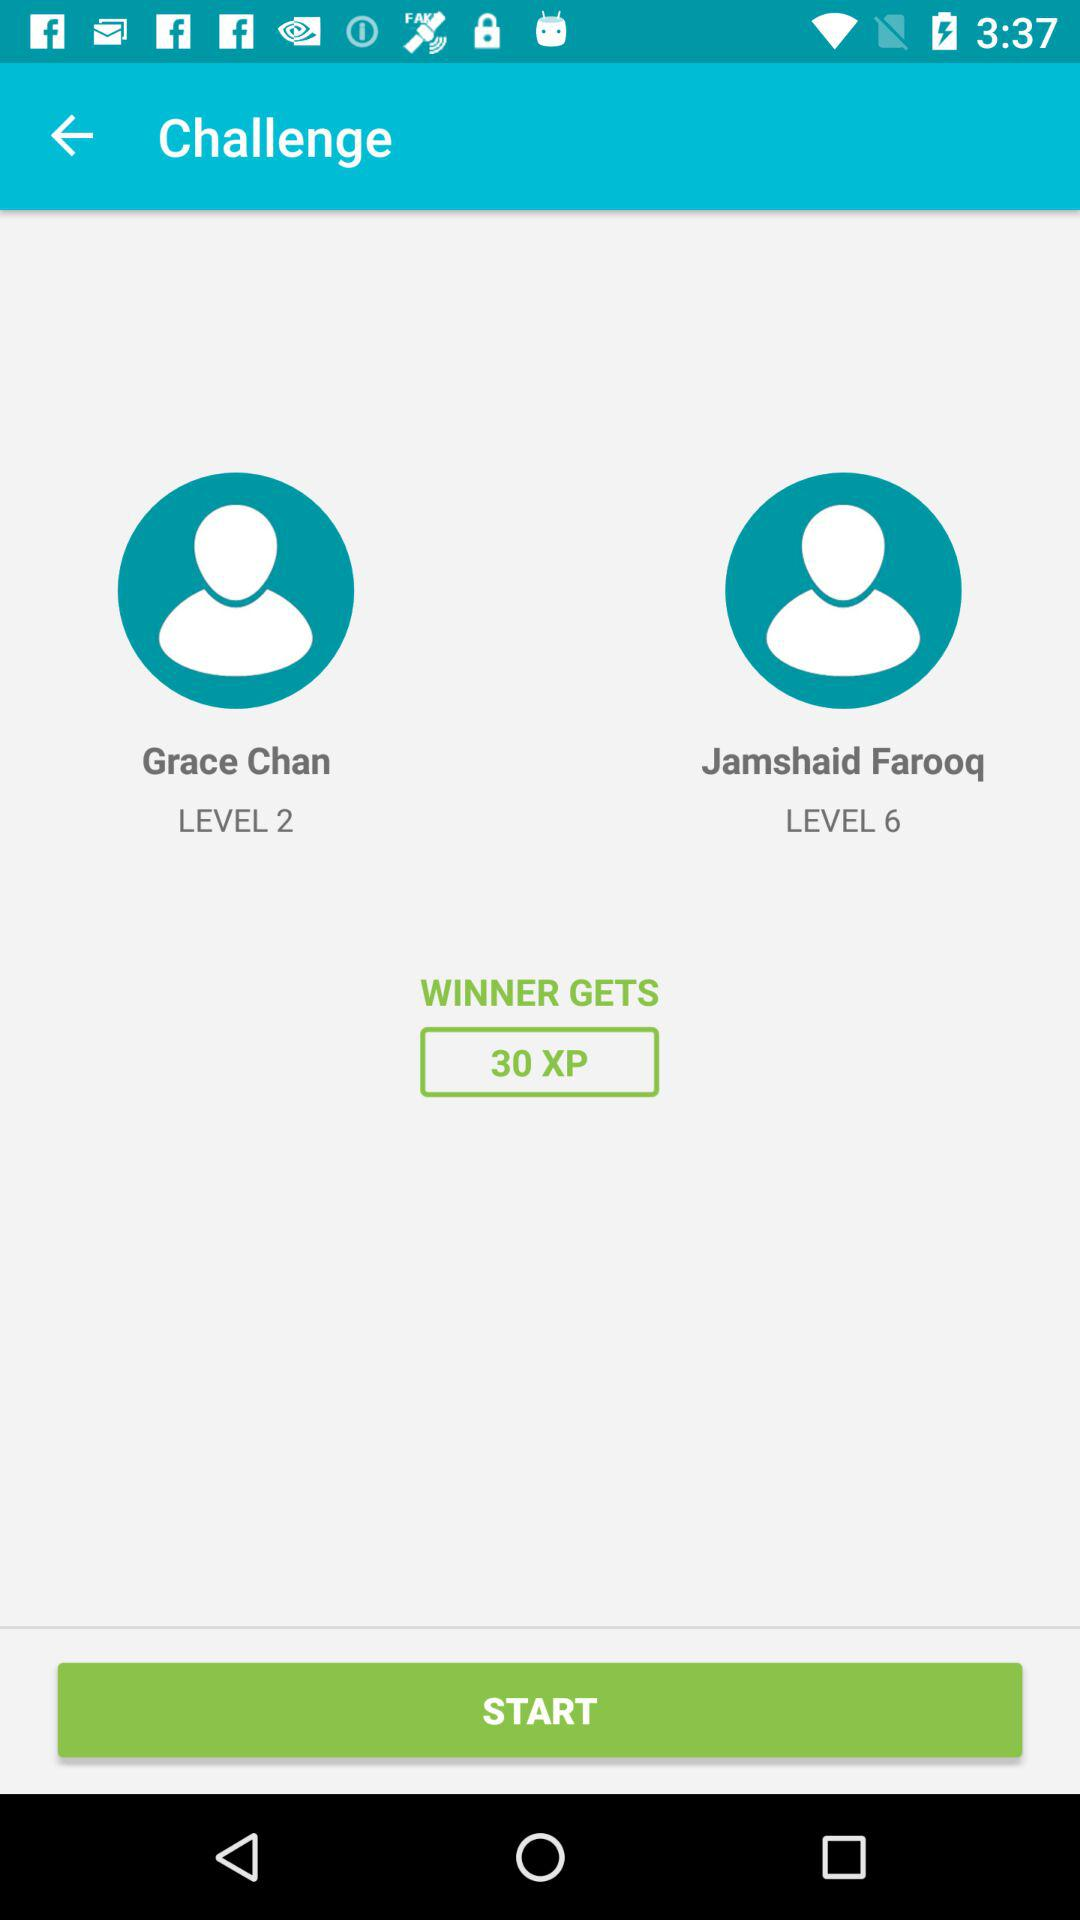How many more levels does Jamshaid Farooq have than Grace Chan?
Answer the question using a single word or phrase. 4 